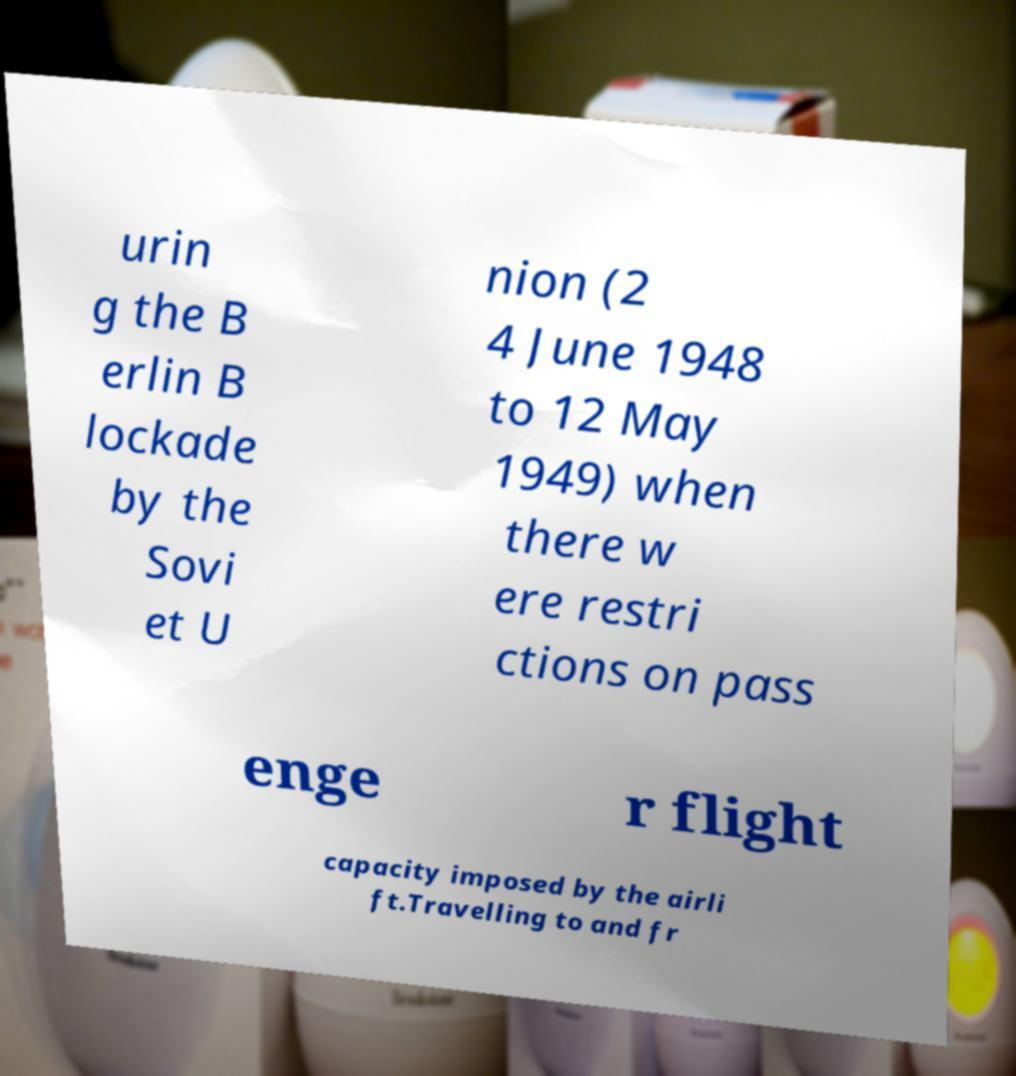For documentation purposes, I need the text within this image transcribed. Could you provide that? urin g the B erlin B lockade by the Sovi et U nion (2 4 June 1948 to 12 May 1949) when there w ere restri ctions on pass enge r flight capacity imposed by the airli ft.Travelling to and fr 